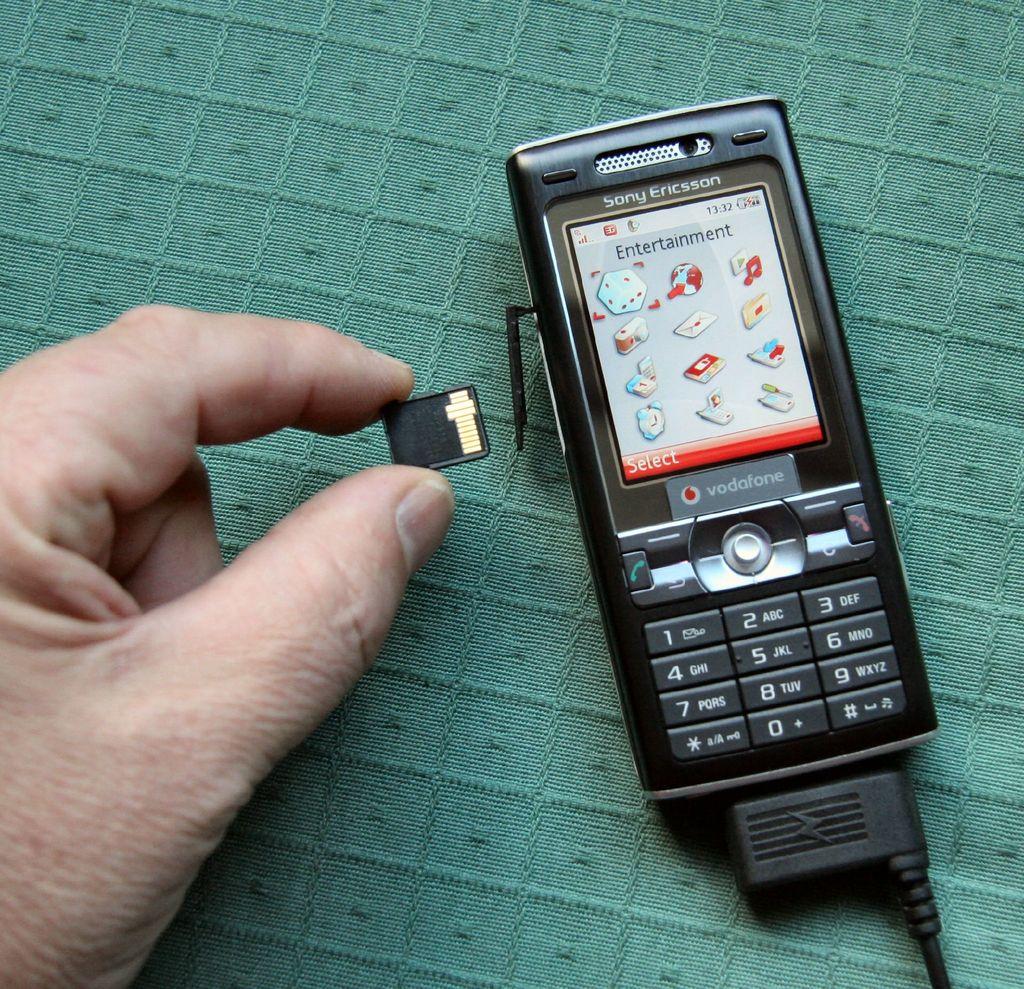Is this a sony phone?
Offer a terse response. Yes. What word is listed in the red line on the phone screen?
Offer a very short reply. Select. 